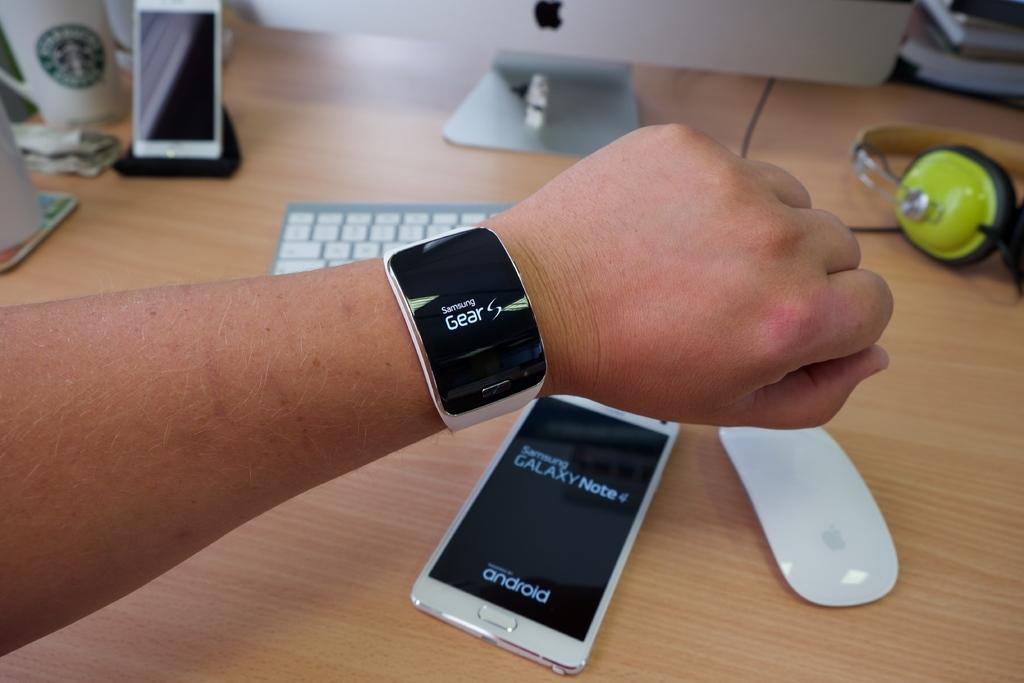<image>
Share a concise interpretation of the image provided. A person is displaying a Samsung Gear smart watch on their wrist. 